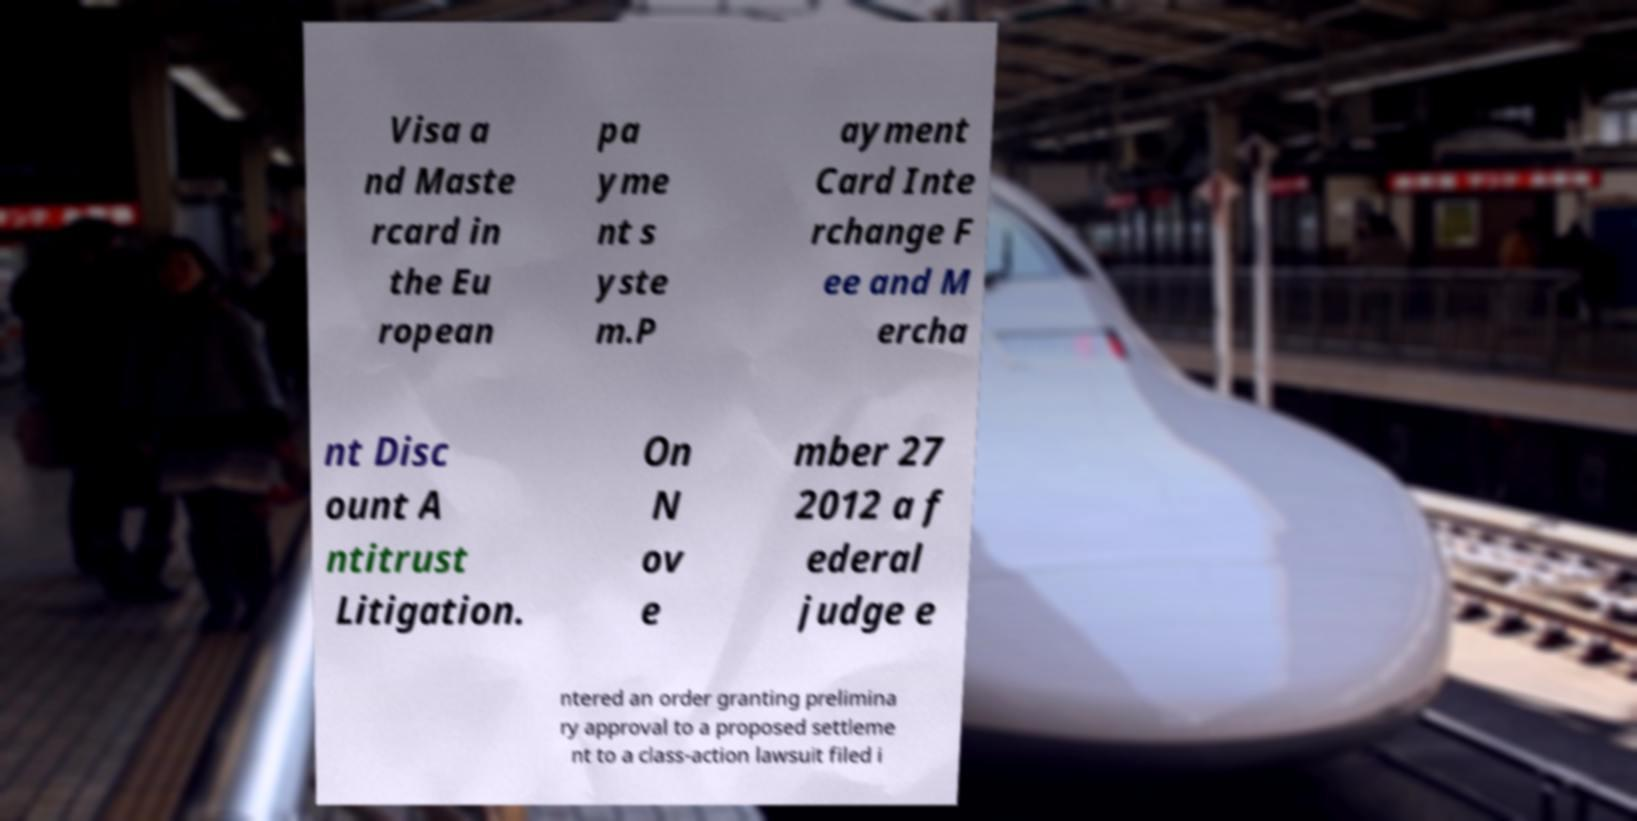Could you extract and type out the text from this image? Visa a nd Maste rcard in the Eu ropean pa yme nt s yste m.P ayment Card Inte rchange F ee and M ercha nt Disc ount A ntitrust Litigation. On N ov e mber 27 2012 a f ederal judge e ntered an order granting prelimina ry approval to a proposed settleme nt to a class-action lawsuit filed i 